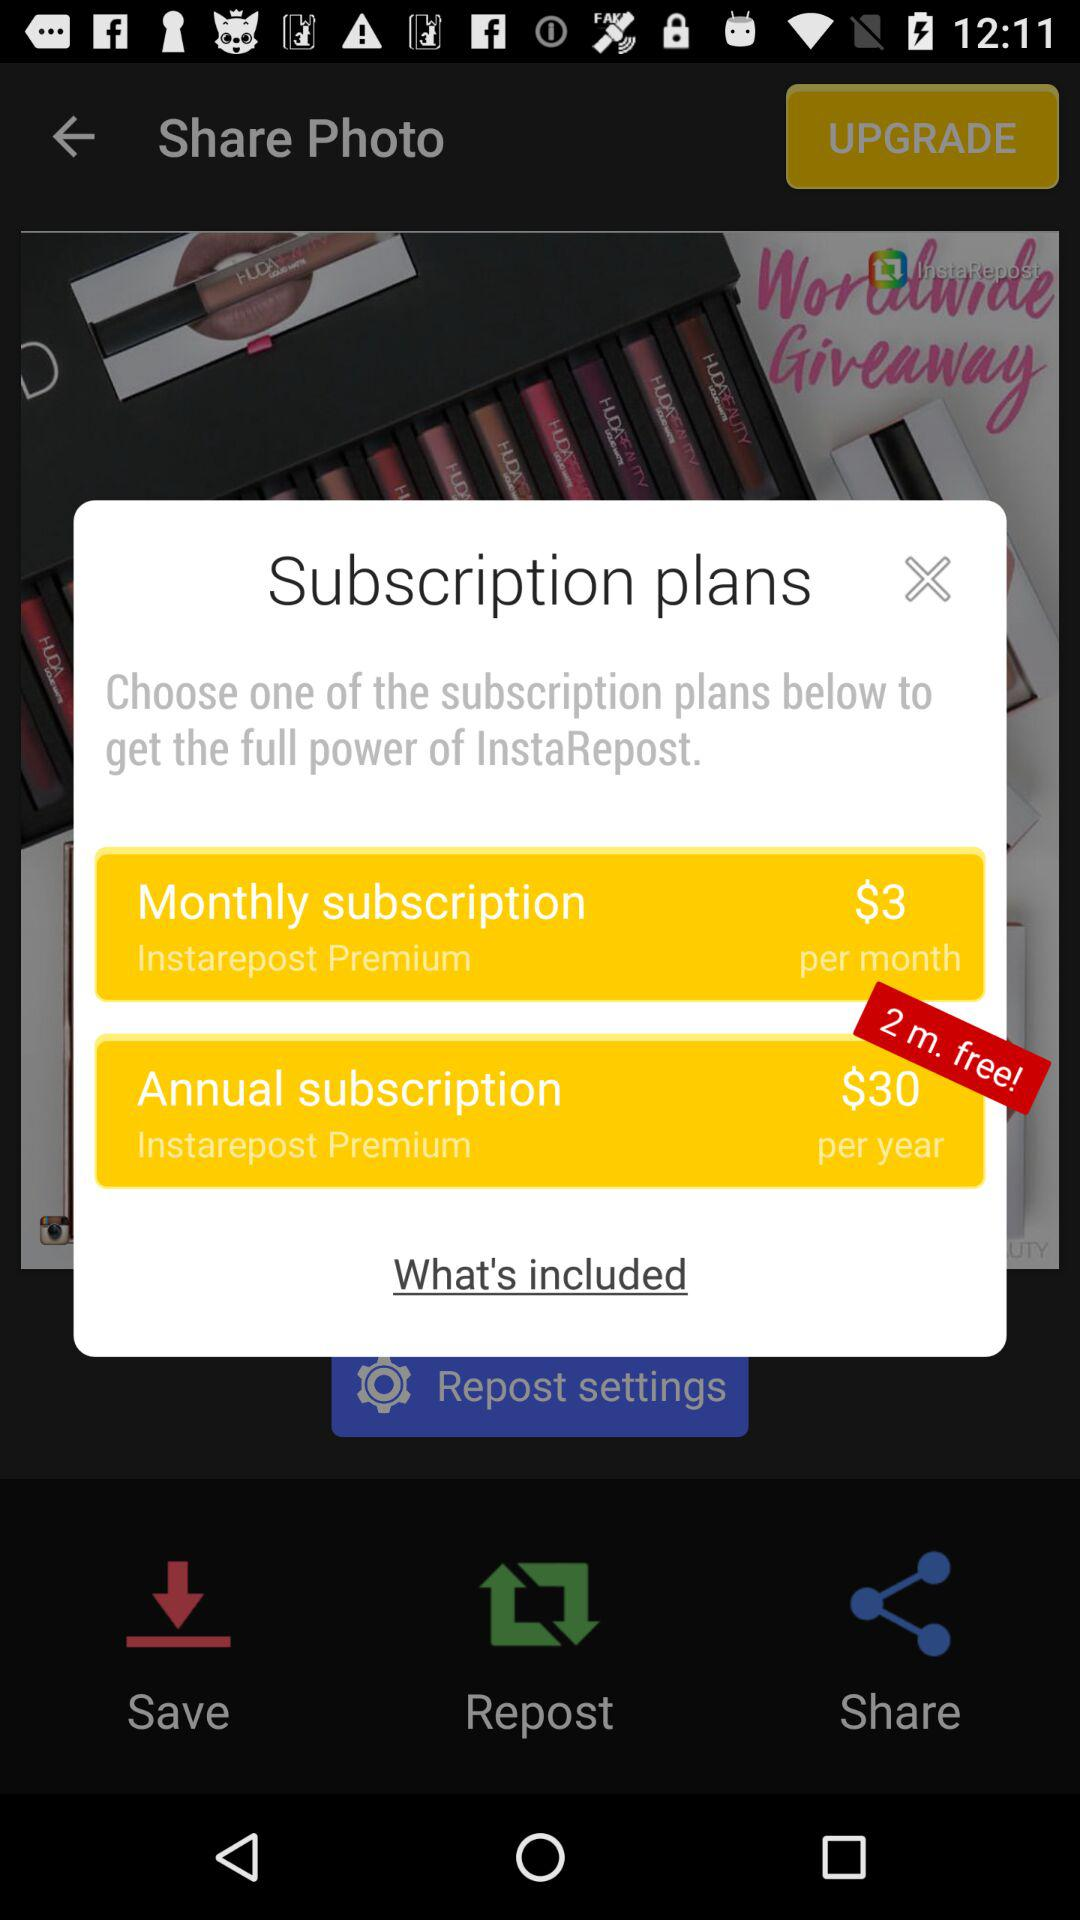Which subscription has given 2 extra months free? The subscription that has given 2 extra months free is "Annual subscription". 